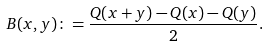Convert formula to latex. <formula><loc_0><loc_0><loc_500><loc_500>B ( x , y ) \colon = \frac { Q ( x + y ) - Q ( x ) - Q ( y ) } { 2 } .</formula> 